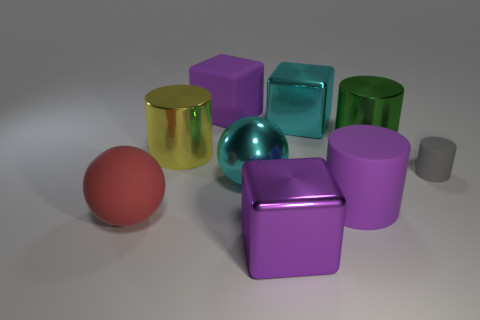Can you tell me which objects in the picture are reflective? Certainly! In the image, the reflective objects include the golden yellow cylinder on the left, a teal cube near the center, and the light blue sphere next to it. You can tell they are reflective because of the light spots and the way they showcase the environment on their surfaces. 